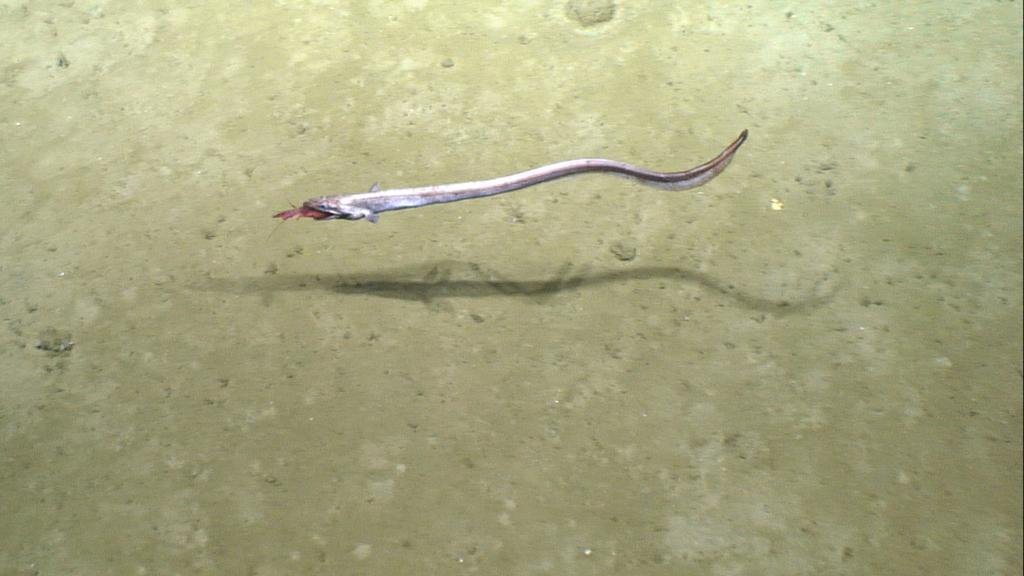What type of animal can be seen in the water in the image? There is a fish in the water in the image. What can be observed on the ground in the image? There is a shadow visible on the ground in the image. How does the beggar interact with the fish in the image? There is no beggar present in the image, so there is no interaction between a beggar and the fish. 